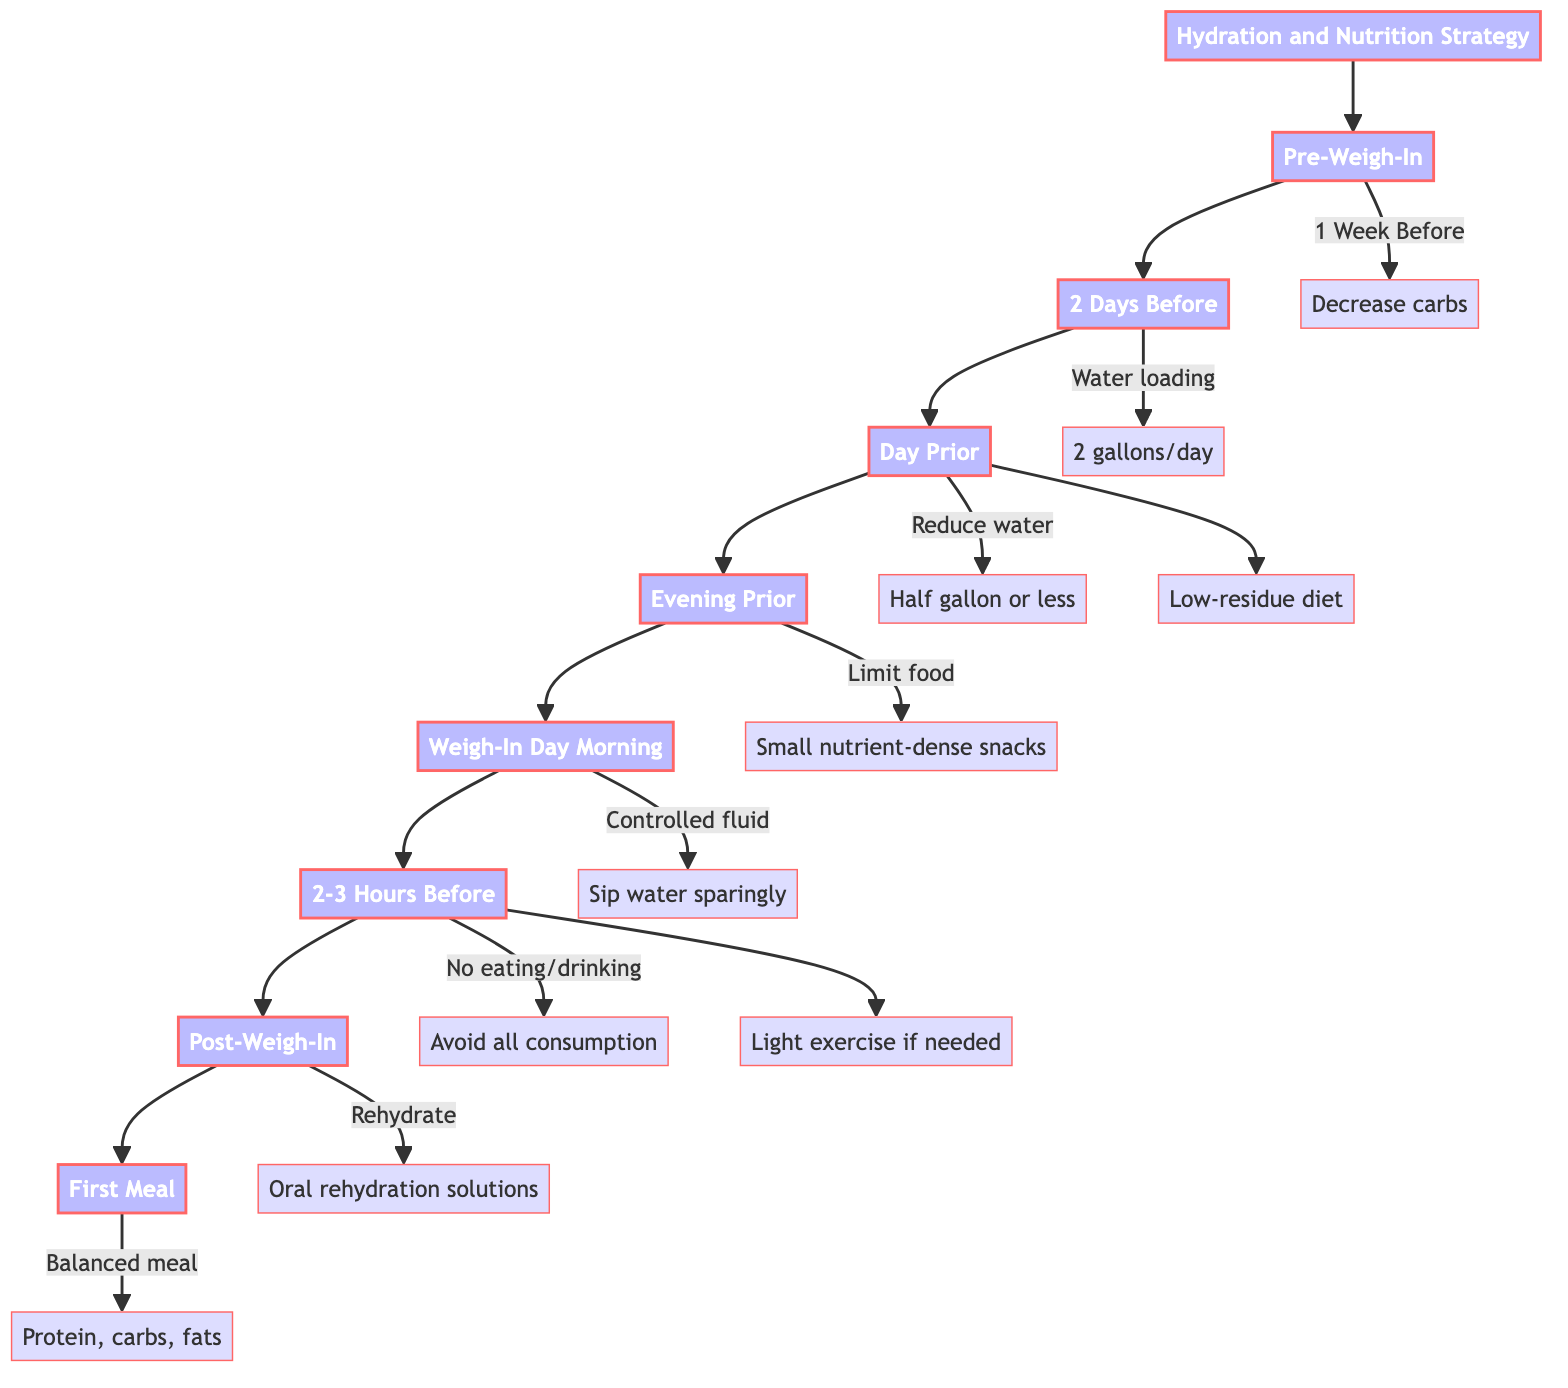What is the first action in the hydration strategy? The first action in the hydration strategy is to decrease carbohydrate intake gradually. This node is the first sub-phase connected to the Pre-Weigh-In node, indicating it occurs one week before the weigh-in.
Answer: Gradual decrease in carbohydrate intake How much water should be consumed two days before the weigh-in? The node for "2 Days Before" states that water loading requires an intake of about 2 gallons per day. It clearly indicates the water intake amount for that time frame.
Answer: 2 gallons per day What is the element that advises on food intake the evening before the weigh-in? The evening prior to the weigh-in focuses on limiting food intake, connecting to the element of limiting meals to small, nutrient-dense snacks. This is a critical instruction to minimize weight before the weigh-in.
Answer: Limit food intake What action should be taken on weigh-in day morning? On weiging day morning, the advised action is controlled fluid intake, which suggests that athletes should sip water sparingly. This information is outlined in that specific node in the flow chart.
Answer: Controlled fluid intake What is the recommended approach for the post-weigh-in first meal? The node for the post-weigh-in first meal indicates that athletes should consume a balanced meal containing lean protein, complex carbohydrates, and healthy fats, to restore energy and refuel muscles.
Answer: Eat a balanced meal Why is light exercise suggested 2-3 hours before the weigh-in? The diagram suggests engaging in light exercise if necessary to shed the last few ounces, connected to the no eating/drinking node in the flow chart. This indicates that the purpose of exercise here is weight management and fine-tuning the athlete's weight just prior to the weigh-in.
Answer: To shed the last few ounces How many main phases are there in the hydration and nutrition strategy? By counting the main phases in the diagram, there are 8 nodes that represent the primary steps in the hydration and nutrition strategy, from Pre-Weigh-In to First Meal after weigh-in. The count includes all significant time periods leading up to and following the weigh-in.
Answer: 8 What type of food is advised in the low-residue diet? The low-residue diet simply states to consume easily digestible, low-fiber foods, specifically mentioning options like white rice, chicken breast, and protein shakes, which supports the objective of reducing weight before weigh-in.
Answer: Easily digestible, low-fiber foods What is the purpose of water loading two days prior? The purpose of water loading is to promote natural diuresis by significantly increasing water intake, thereby encouraging the body to excrete excess water as indicated in the node for 2 days before. This underlines the importance of understanding fluid retention in weight management.
Answer: Promote natural diuresis 